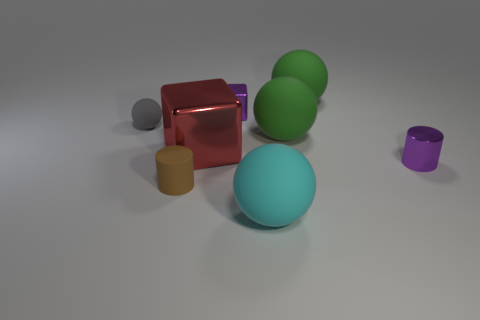Subtract all gray matte spheres. How many spheres are left? 3 Add 1 green metallic objects. How many objects exist? 9 Subtract all purple cylinders. How many cylinders are left? 1 Add 5 small matte things. How many small matte things exist? 7 Subtract 1 purple cylinders. How many objects are left? 7 Subtract all cylinders. How many objects are left? 6 Subtract 3 balls. How many balls are left? 1 Subtract all brown cubes. Subtract all gray cylinders. How many cubes are left? 2 Subtract all brown cylinders. How many green spheres are left? 2 Subtract all big green matte blocks. Subtract all big green rubber things. How many objects are left? 6 